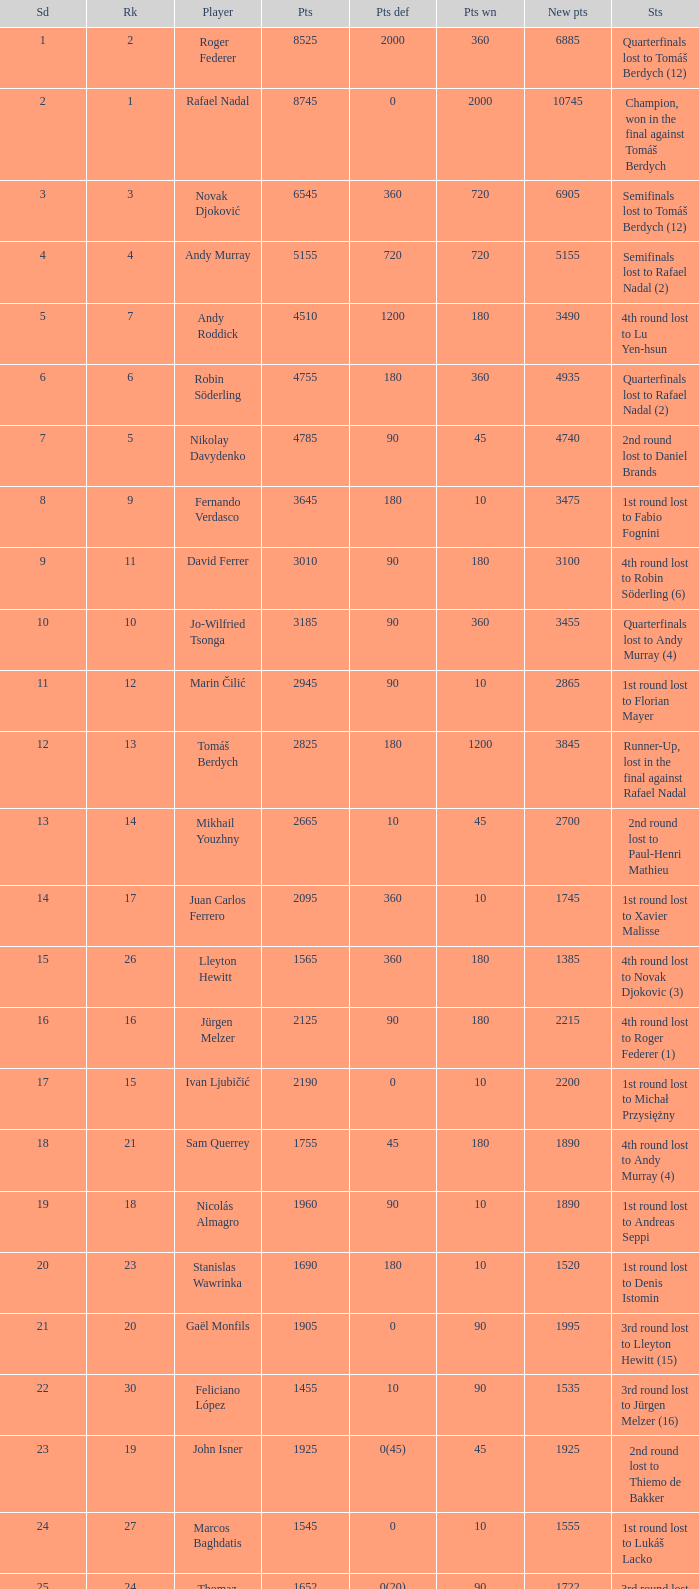Name the least new points for points defending is 1200 3490.0. 